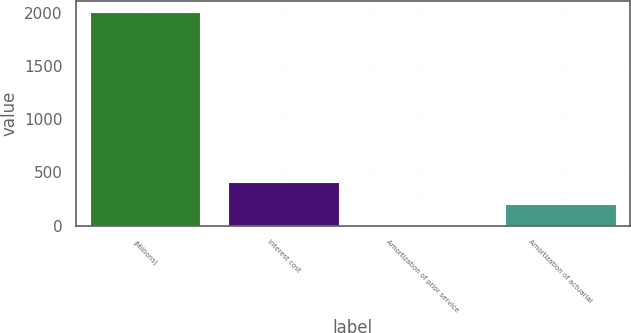Convert chart. <chart><loc_0><loc_0><loc_500><loc_500><bar_chart><fcel>(Millions)<fcel>Interest cost<fcel>Amortization of prior service<fcel>Amortization of actuarial<nl><fcel>2009<fcel>406.6<fcel>6<fcel>206.3<nl></chart> 